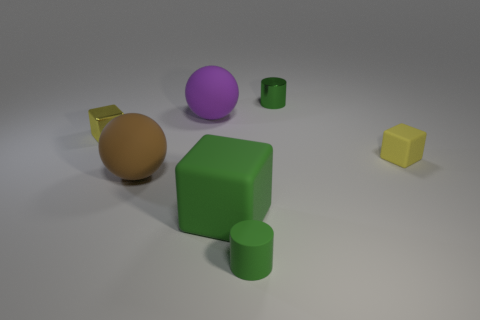What material is the other cube that is the same color as the metallic block?
Your answer should be very brief. Rubber. What is the shape of the shiny thing that is in front of the small metallic cylinder that is to the left of the tiny rubber cube?
Your response must be concise. Cube. Is there a cyan cube that has the same size as the yellow metal object?
Ensure brevity in your answer.  No. Do the cube behind the small yellow rubber cube and the tiny rubber cylinder have the same color?
Your answer should be very brief. No. How many objects are rubber objects or large objects?
Your answer should be very brief. 5. Is the size of the rubber sphere behind the brown ball the same as the brown matte thing?
Make the answer very short. Yes. How big is the rubber thing that is both in front of the large purple ball and on the left side of the large green matte block?
Make the answer very short. Large. What number of other objects are there of the same shape as the large purple matte thing?
Provide a succinct answer. 1. How many other things are there of the same material as the green cube?
Your response must be concise. 4. What is the size of the yellow metallic thing that is the same shape as the large green object?
Keep it short and to the point. Small. 